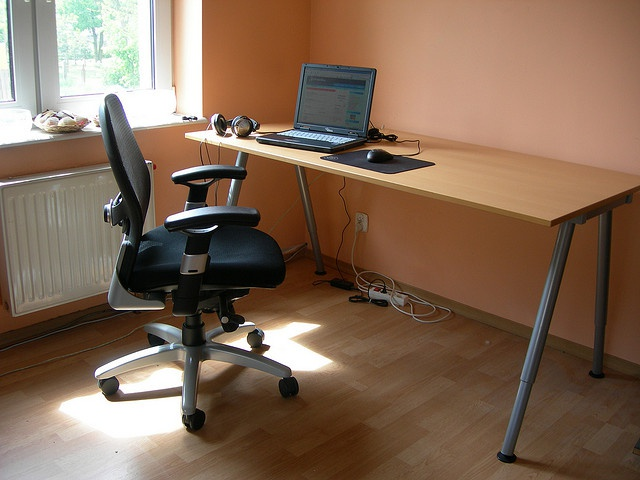Describe the objects in this image and their specific colors. I can see chair in white, black, gray, and darkblue tones, laptop in white, purple, black, and darkblue tones, and mouse in white, black, gray, and maroon tones in this image. 